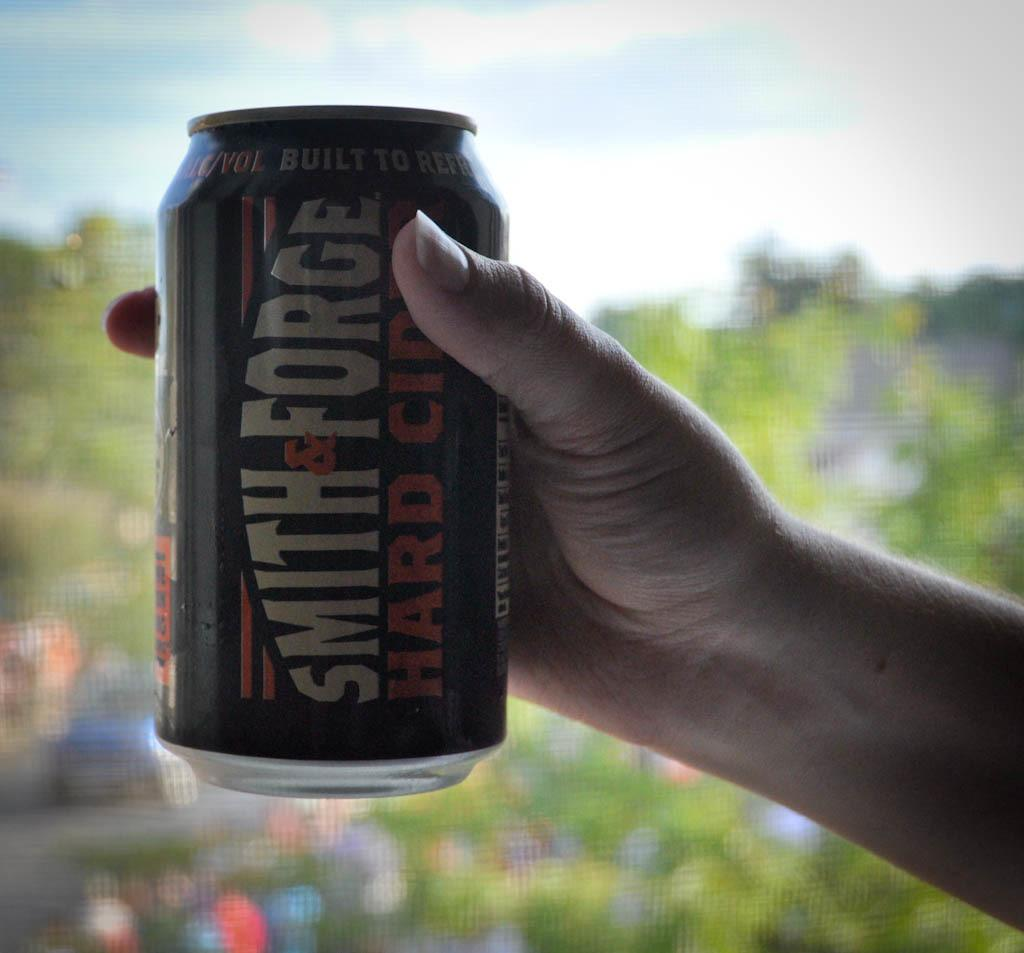<image>
Write a terse but informative summary of the picture. A can of Smith and Forge hard cider is being held out by someone. 